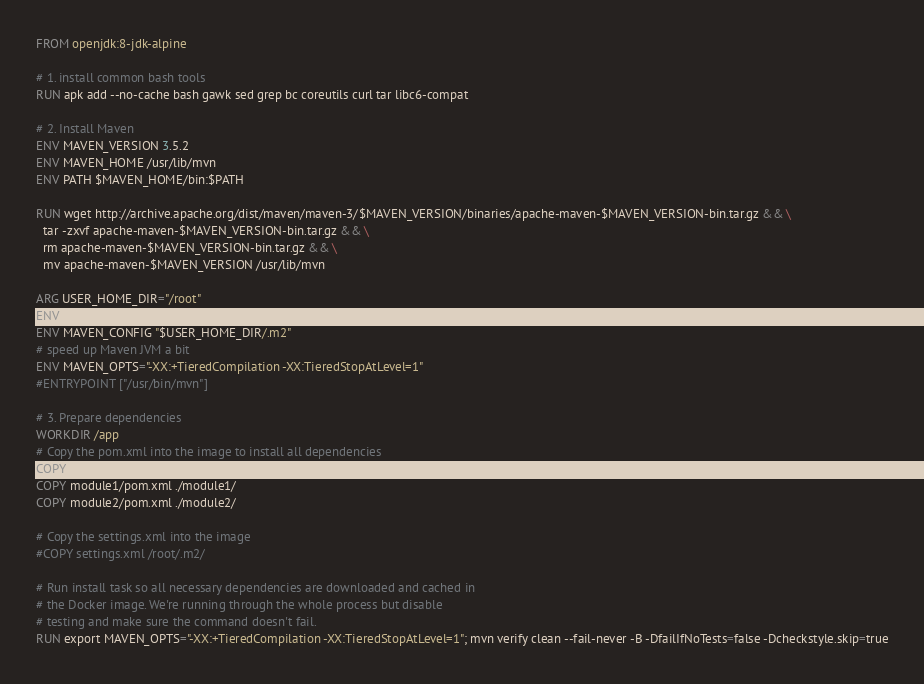Convert code to text. <code><loc_0><loc_0><loc_500><loc_500><_Dockerfile_>FROM openjdk:8-jdk-alpine

# 1. install common bash tools
RUN apk add --no-cache bash gawk sed grep bc coreutils curl tar libc6-compat

# 2. Install Maven
ENV MAVEN_VERSION 3.5.2
ENV MAVEN_HOME /usr/lib/mvn
ENV PATH $MAVEN_HOME/bin:$PATH

RUN wget http://archive.apache.org/dist/maven/maven-3/$MAVEN_VERSION/binaries/apache-maven-$MAVEN_VERSION-bin.tar.gz && \
  tar -zxvf apache-maven-$MAVEN_VERSION-bin.tar.gz && \
  rm apache-maven-$MAVEN_VERSION-bin.tar.gz && \
  mv apache-maven-$MAVEN_VERSION /usr/lib/mvn

ARG USER_HOME_DIR="/root"
ENV MAVEN_HOME /usr/lib/mvn
ENV MAVEN_CONFIG "$USER_HOME_DIR/.m2"
# speed up Maven JVM a bit
ENV MAVEN_OPTS="-XX:+TieredCompilation -XX:TieredStopAtLevel=1"
#ENTRYPOINT ["/usr/bin/mvn"]

# 3. Prepare dependencies
WORKDIR /app
# Copy the pom.xml into the image to install all dependencies
COPY pom.xml ./
COPY module1/pom.xml ./module1/
COPY module2/pom.xml ./module2/

# Copy the settings.xml into the image
#COPY settings.xml /root/.m2/

# Run install task so all necessary dependencies are downloaded and cached in
# the Docker image. We're running through the whole process but disable
# testing and make sure the command doesn't fail.
RUN export MAVEN_OPTS="-XX:+TieredCompilation -XX:TieredStopAtLevel=1"; mvn verify clean --fail-never -B -DfailIfNoTests=false -Dcheckstyle.skip=true
</code> 